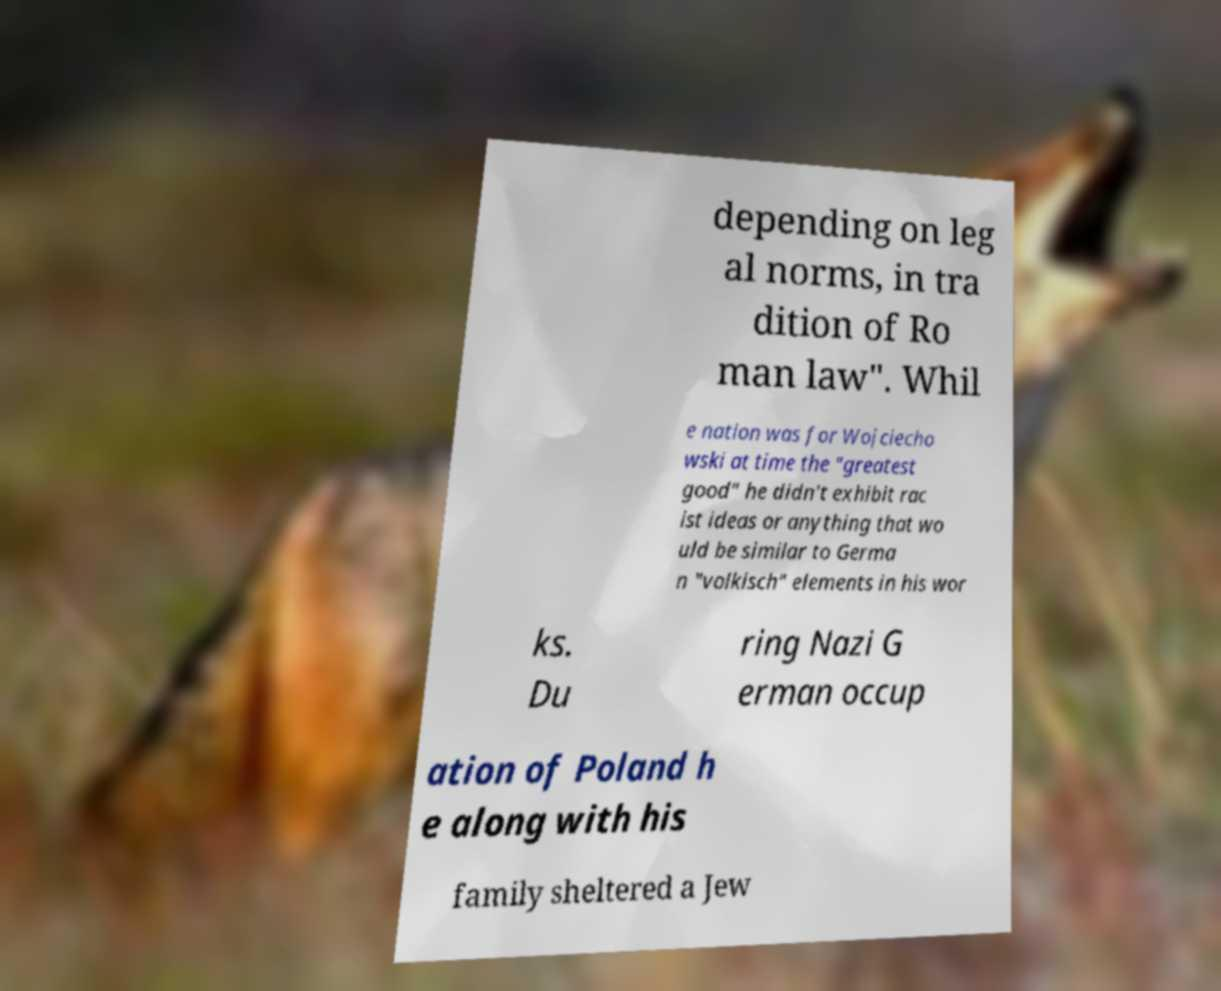For documentation purposes, I need the text within this image transcribed. Could you provide that? depending on leg al norms, in tra dition of Ro man law". Whil e nation was for Wojciecho wski at time the "greatest good" he didn't exhibit rac ist ideas or anything that wo uld be similar to Germa n "volkisch" elements in his wor ks. Du ring Nazi G erman occup ation of Poland h e along with his family sheltered a Jew 